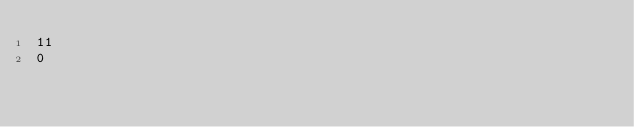Convert code to text. <code><loc_0><loc_0><loc_500><loc_500><_SQL_>11
0</code> 